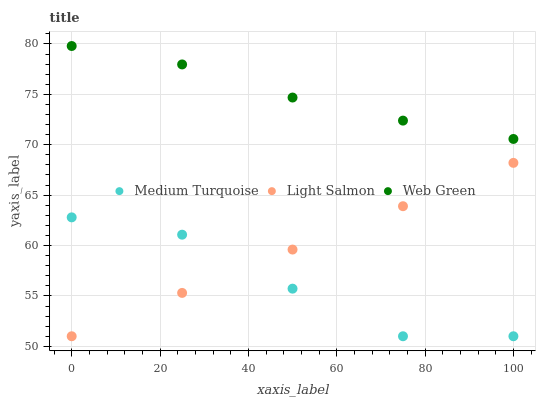Does Medium Turquoise have the minimum area under the curve?
Answer yes or no. Yes. Does Web Green have the maximum area under the curve?
Answer yes or no. Yes. Does Web Green have the minimum area under the curve?
Answer yes or no. No. Does Medium Turquoise have the maximum area under the curve?
Answer yes or no. No. Is Light Salmon the smoothest?
Answer yes or no. Yes. Is Medium Turquoise the roughest?
Answer yes or no. Yes. Is Web Green the smoothest?
Answer yes or no. No. Is Web Green the roughest?
Answer yes or no. No. Does Light Salmon have the lowest value?
Answer yes or no. Yes. Does Web Green have the lowest value?
Answer yes or no. No. Does Web Green have the highest value?
Answer yes or no. Yes. Does Medium Turquoise have the highest value?
Answer yes or no. No. Is Medium Turquoise less than Web Green?
Answer yes or no. Yes. Is Web Green greater than Medium Turquoise?
Answer yes or no. Yes. Does Medium Turquoise intersect Light Salmon?
Answer yes or no. Yes. Is Medium Turquoise less than Light Salmon?
Answer yes or no. No. Is Medium Turquoise greater than Light Salmon?
Answer yes or no. No. Does Medium Turquoise intersect Web Green?
Answer yes or no. No. 